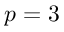<formula> <loc_0><loc_0><loc_500><loc_500>p = 3</formula> 